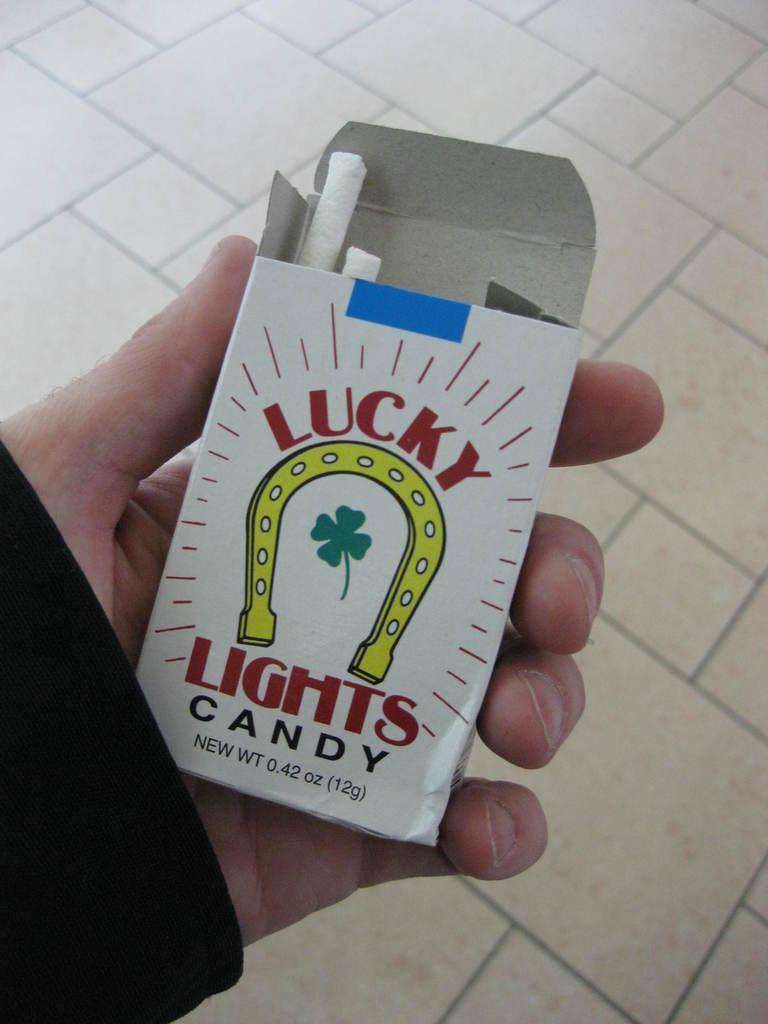What can be seen in the image related to a person's hand? There is a person's hand in the image, and it is holding a cigarette pack. What is the main object being held by the hand in the image? The hand is holding a cigarette pack. What can be seen in the background of the image? The background of the image includes the floor. What type of pig can be seen in the image? There is no pig present in the image. What letter is written on the cigarette pack in the image? The cigarette pack in the image does not have any visible letters. 